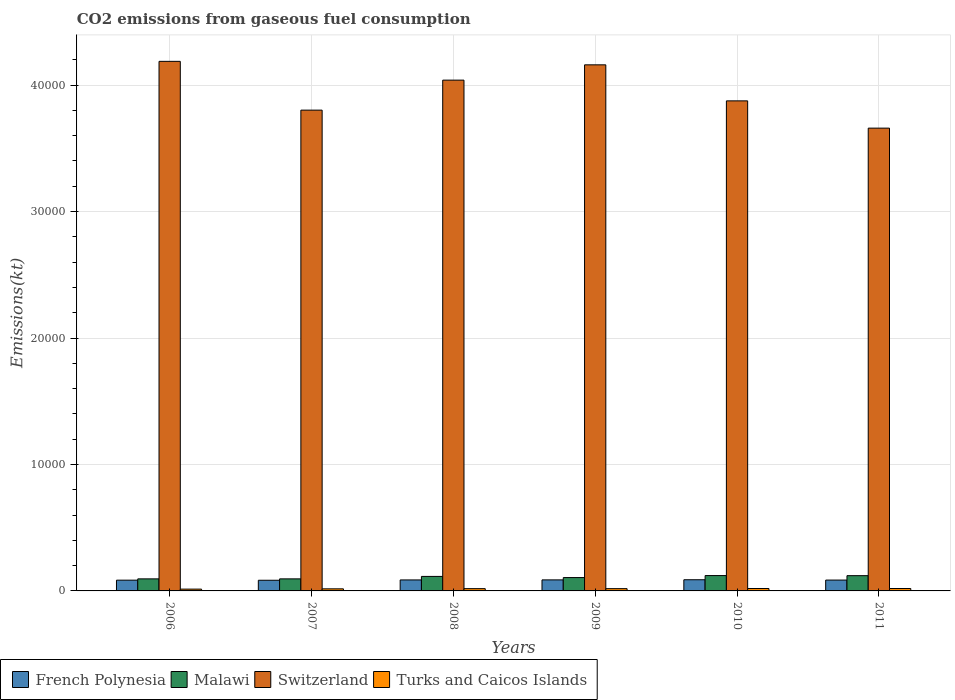How many bars are there on the 5th tick from the right?
Offer a very short reply. 4. What is the amount of CO2 emitted in Turks and Caicos Islands in 2011?
Give a very brief answer. 190.68. Across all years, what is the maximum amount of CO2 emitted in French Polynesia?
Ensure brevity in your answer.  883.75. Across all years, what is the minimum amount of CO2 emitted in Malawi?
Your answer should be compact. 953.42. In which year was the amount of CO2 emitted in Turks and Caicos Islands maximum?
Make the answer very short. 2010. What is the total amount of CO2 emitted in French Polynesia in the graph?
Ensure brevity in your answer.  5177.8. What is the difference between the amount of CO2 emitted in French Polynesia in 2006 and that in 2007?
Your answer should be very brief. 7.33. What is the difference between the amount of CO2 emitted in Switzerland in 2011 and the amount of CO2 emitted in French Polynesia in 2010?
Provide a short and direct response. 3.57e+04. What is the average amount of CO2 emitted in French Polynesia per year?
Provide a short and direct response. 862.97. In the year 2006, what is the difference between the amount of CO2 emitted in French Polynesia and amount of CO2 emitted in Malawi?
Make the answer very short. -102.68. In how many years, is the amount of CO2 emitted in Switzerland greater than 30000 kt?
Your response must be concise. 6. What is the ratio of the amount of CO2 emitted in Malawi in 2009 to that in 2011?
Provide a short and direct response. 0.88. Is the amount of CO2 emitted in French Polynesia in 2007 less than that in 2008?
Give a very brief answer. Yes. What is the difference between the highest and the second highest amount of CO2 emitted in Malawi?
Your response must be concise. 7.33. What is the difference between the highest and the lowest amount of CO2 emitted in Malawi?
Provide a succinct answer. 260.36. In how many years, is the amount of CO2 emitted in Turks and Caicos Islands greater than the average amount of CO2 emitted in Turks and Caicos Islands taken over all years?
Offer a terse response. 4. Is it the case that in every year, the sum of the amount of CO2 emitted in French Polynesia and amount of CO2 emitted in Turks and Caicos Islands is greater than the sum of amount of CO2 emitted in Switzerland and amount of CO2 emitted in Malawi?
Ensure brevity in your answer.  No. What does the 2nd bar from the left in 2009 represents?
Ensure brevity in your answer.  Malawi. What does the 4th bar from the right in 2007 represents?
Provide a short and direct response. French Polynesia. Is it the case that in every year, the sum of the amount of CO2 emitted in Switzerland and amount of CO2 emitted in Turks and Caicos Islands is greater than the amount of CO2 emitted in Malawi?
Offer a terse response. Yes. What is the difference between two consecutive major ticks on the Y-axis?
Offer a terse response. 10000. Are the values on the major ticks of Y-axis written in scientific E-notation?
Provide a succinct answer. No. Does the graph contain any zero values?
Provide a succinct answer. No. Does the graph contain grids?
Ensure brevity in your answer.  Yes. Where does the legend appear in the graph?
Keep it short and to the point. Bottom left. How many legend labels are there?
Your answer should be very brief. 4. What is the title of the graph?
Provide a succinct answer. CO2 emissions from gaseous fuel consumption. What is the label or title of the Y-axis?
Give a very brief answer. Emissions(kt). What is the Emissions(kt) in French Polynesia in 2006?
Provide a short and direct response. 850.74. What is the Emissions(kt) of Malawi in 2006?
Your answer should be compact. 953.42. What is the Emissions(kt) of Switzerland in 2006?
Keep it short and to the point. 4.19e+04. What is the Emissions(kt) of Turks and Caicos Islands in 2006?
Keep it short and to the point. 143.01. What is the Emissions(kt) of French Polynesia in 2007?
Provide a short and direct response. 843.41. What is the Emissions(kt) of Malawi in 2007?
Provide a succinct answer. 953.42. What is the Emissions(kt) of Switzerland in 2007?
Your response must be concise. 3.80e+04. What is the Emissions(kt) in Turks and Caicos Islands in 2007?
Give a very brief answer. 165.01. What is the Emissions(kt) in French Polynesia in 2008?
Offer a very short reply. 869.08. What is the Emissions(kt) of Malawi in 2008?
Provide a short and direct response. 1147.77. What is the Emissions(kt) of Switzerland in 2008?
Provide a short and direct response. 4.04e+04. What is the Emissions(kt) of Turks and Caicos Islands in 2008?
Your answer should be compact. 179.68. What is the Emissions(kt) in French Polynesia in 2009?
Your answer should be compact. 872.75. What is the Emissions(kt) of Malawi in 2009?
Your answer should be compact. 1056.1. What is the Emissions(kt) in Switzerland in 2009?
Make the answer very short. 4.16e+04. What is the Emissions(kt) in Turks and Caicos Islands in 2009?
Offer a terse response. 179.68. What is the Emissions(kt) of French Polynesia in 2010?
Provide a succinct answer. 883.75. What is the Emissions(kt) of Malawi in 2010?
Give a very brief answer. 1213.78. What is the Emissions(kt) in Switzerland in 2010?
Your answer should be compact. 3.88e+04. What is the Emissions(kt) in Turks and Caicos Islands in 2010?
Provide a short and direct response. 190.68. What is the Emissions(kt) of French Polynesia in 2011?
Provide a short and direct response. 858.08. What is the Emissions(kt) in Malawi in 2011?
Ensure brevity in your answer.  1206.44. What is the Emissions(kt) in Switzerland in 2011?
Offer a terse response. 3.66e+04. What is the Emissions(kt) in Turks and Caicos Islands in 2011?
Your answer should be very brief. 190.68. Across all years, what is the maximum Emissions(kt) of French Polynesia?
Your answer should be very brief. 883.75. Across all years, what is the maximum Emissions(kt) of Malawi?
Provide a succinct answer. 1213.78. Across all years, what is the maximum Emissions(kt) of Switzerland?
Give a very brief answer. 4.19e+04. Across all years, what is the maximum Emissions(kt) of Turks and Caicos Islands?
Your answer should be compact. 190.68. Across all years, what is the minimum Emissions(kt) in French Polynesia?
Make the answer very short. 843.41. Across all years, what is the minimum Emissions(kt) in Malawi?
Offer a very short reply. 953.42. Across all years, what is the minimum Emissions(kt) of Switzerland?
Your answer should be very brief. 3.66e+04. Across all years, what is the minimum Emissions(kt) of Turks and Caicos Islands?
Ensure brevity in your answer.  143.01. What is the total Emissions(kt) in French Polynesia in the graph?
Offer a terse response. 5177.8. What is the total Emissions(kt) of Malawi in the graph?
Give a very brief answer. 6530.93. What is the total Emissions(kt) in Switzerland in the graph?
Ensure brevity in your answer.  2.37e+05. What is the total Emissions(kt) in Turks and Caicos Islands in the graph?
Offer a very short reply. 1048.76. What is the difference between the Emissions(kt) in French Polynesia in 2006 and that in 2007?
Provide a succinct answer. 7.33. What is the difference between the Emissions(kt) of Switzerland in 2006 and that in 2007?
Give a very brief answer. 3857.68. What is the difference between the Emissions(kt) in Turks and Caicos Islands in 2006 and that in 2007?
Give a very brief answer. -22. What is the difference between the Emissions(kt) of French Polynesia in 2006 and that in 2008?
Provide a succinct answer. -18.34. What is the difference between the Emissions(kt) of Malawi in 2006 and that in 2008?
Offer a terse response. -194.35. What is the difference between the Emissions(kt) in Switzerland in 2006 and that in 2008?
Ensure brevity in your answer.  1485.13. What is the difference between the Emissions(kt) in Turks and Caicos Islands in 2006 and that in 2008?
Provide a short and direct response. -36.67. What is the difference between the Emissions(kt) in French Polynesia in 2006 and that in 2009?
Your answer should be very brief. -22. What is the difference between the Emissions(kt) in Malawi in 2006 and that in 2009?
Offer a terse response. -102.68. What is the difference between the Emissions(kt) of Switzerland in 2006 and that in 2009?
Make the answer very short. 275.02. What is the difference between the Emissions(kt) of Turks and Caicos Islands in 2006 and that in 2009?
Your response must be concise. -36.67. What is the difference between the Emissions(kt) of French Polynesia in 2006 and that in 2010?
Ensure brevity in your answer.  -33. What is the difference between the Emissions(kt) in Malawi in 2006 and that in 2010?
Your response must be concise. -260.36. What is the difference between the Emissions(kt) of Switzerland in 2006 and that in 2010?
Offer a very short reply. 3124.28. What is the difference between the Emissions(kt) in Turks and Caicos Islands in 2006 and that in 2010?
Offer a very short reply. -47.67. What is the difference between the Emissions(kt) of French Polynesia in 2006 and that in 2011?
Offer a very short reply. -7.33. What is the difference between the Emissions(kt) of Malawi in 2006 and that in 2011?
Make the answer very short. -253.02. What is the difference between the Emissions(kt) in Switzerland in 2006 and that in 2011?
Make the answer very short. 5280.48. What is the difference between the Emissions(kt) in Turks and Caicos Islands in 2006 and that in 2011?
Your answer should be compact. -47.67. What is the difference between the Emissions(kt) in French Polynesia in 2007 and that in 2008?
Provide a short and direct response. -25.67. What is the difference between the Emissions(kt) in Malawi in 2007 and that in 2008?
Keep it short and to the point. -194.35. What is the difference between the Emissions(kt) of Switzerland in 2007 and that in 2008?
Provide a short and direct response. -2372.55. What is the difference between the Emissions(kt) in Turks and Caicos Islands in 2007 and that in 2008?
Ensure brevity in your answer.  -14.67. What is the difference between the Emissions(kt) in French Polynesia in 2007 and that in 2009?
Give a very brief answer. -29.34. What is the difference between the Emissions(kt) in Malawi in 2007 and that in 2009?
Keep it short and to the point. -102.68. What is the difference between the Emissions(kt) in Switzerland in 2007 and that in 2009?
Ensure brevity in your answer.  -3582.66. What is the difference between the Emissions(kt) in Turks and Caicos Islands in 2007 and that in 2009?
Your answer should be very brief. -14.67. What is the difference between the Emissions(kt) in French Polynesia in 2007 and that in 2010?
Offer a terse response. -40.34. What is the difference between the Emissions(kt) in Malawi in 2007 and that in 2010?
Provide a succinct answer. -260.36. What is the difference between the Emissions(kt) of Switzerland in 2007 and that in 2010?
Provide a succinct answer. -733.4. What is the difference between the Emissions(kt) in Turks and Caicos Islands in 2007 and that in 2010?
Ensure brevity in your answer.  -25.67. What is the difference between the Emissions(kt) in French Polynesia in 2007 and that in 2011?
Offer a terse response. -14.67. What is the difference between the Emissions(kt) in Malawi in 2007 and that in 2011?
Keep it short and to the point. -253.02. What is the difference between the Emissions(kt) in Switzerland in 2007 and that in 2011?
Keep it short and to the point. 1422.8. What is the difference between the Emissions(kt) of Turks and Caicos Islands in 2007 and that in 2011?
Give a very brief answer. -25.67. What is the difference between the Emissions(kt) of French Polynesia in 2008 and that in 2009?
Keep it short and to the point. -3.67. What is the difference between the Emissions(kt) of Malawi in 2008 and that in 2009?
Offer a terse response. 91.67. What is the difference between the Emissions(kt) in Switzerland in 2008 and that in 2009?
Offer a terse response. -1210.11. What is the difference between the Emissions(kt) in French Polynesia in 2008 and that in 2010?
Make the answer very short. -14.67. What is the difference between the Emissions(kt) in Malawi in 2008 and that in 2010?
Provide a short and direct response. -66.01. What is the difference between the Emissions(kt) of Switzerland in 2008 and that in 2010?
Your response must be concise. 1639.15. What is the difference between the Emissions(kt) of Turks and Caicos Islands in 2008 and that in 2010?
Provide a short and direct response. -11. What is the difference between the Emissions(kt) in French Polynesia in 2008 and that in 2011?
Your answer should be compact. 11. What is the difference between the Emissions(kt) in Malawi in 2008 and that in 2011?
Offer a terse response. -58.67. What is the difference between the Emissions(kt) in Switzerland in 2008 and that in 2011?
Provide a succinct answer. 3795.34. What is the difference between the Emissions(kt) of Turks and Caicos Islands in 2008 and that in 2011?
Your response must be concise. -11. What is the difference between the Emissions(kt) in French Polynesia in 2009 and that in 2010?
Your answer should be very brief. -11. What is the difference between the Emissions(kt) of Malawi in 2009 and that in 2010?
Give a very brief answer. -157.68. What is the difference between the Emissions(kt) of Switzerland in 2009 and that in 2010?
Ensure brevity in your answer.  2849.26. What is the difference between the Emissions(kt) of Turks and Caicos Islands in 2009 and that in 2010?
Offer a terse response. -11. What is the difference between the Emissions(kt) of French Polynesia in 2009 and that in 2011?
Make the answer very short. 14.67. What is the difference between the Emissions(kt) in Malawi in 2009 and that in 2011?
Give a very brief answer. -150.35. What is the difference between the Emissions(kt) of Switzerland in 2009 and that in 2011?
Keep it short and to the point. 5005.45. What is the difference between the Emissions(kt) of Turks and Caicos Islands in 2009 and that in 2011?
Provide a short and direct response. -11. What is the difference between the Emissions(kt) of French Polynesia in 2010 and that in 2011?
Your answer should be very brief. 25.67. What is the difference between the Emissions(kt) in Malawi in 2010 and that in 2011?
Ensure brevity in your answer.  7.33. What is the difference between the Emissions(kt) of Switzerland in 2010 and that in 2011?
Your answer should be very brief. 2156.2. What is the difference between the Emissions(kt) of French Polynesia in 2006 and the Emissions(kt) of Malawi in 2007?
Give a very brief answer. -102.68. What is the difference between the Emissions(kt) in French Polynesia in 2006 and the Emissions(kt) in Switzerland in 2007?
Offer a very short reply. -3.72e+04. What is the difference between the Emissions(kt) in French Polynesia in 2006 and the Emissions(kt) in Turks and Caicos Islands in 2007?
Provide a short and direct response. 685.73. What is the difference between the Emissions(kt) of Malawi in 2006 and the Emissions(kt) of Switzerland in 2007?
Offer a terse response. -3.71e+04. What is the difference between the Emissions(kt) of Malawi in 2006 and the Emissions(kt) of Turks and Caicos Islands in 2007?
Provide a succinct answer. 788.4. What is the difference between the Emissions(kt) of Switzerland in 2006 and the Emissions(kt) of Turks and Caicos Islands in 2007?
Offer a very short reply. 4.17e+04. What is the difference between the Emissions(kt) of French Polynesia in 2006 and the Emissions(kt) of Malawi in 2008?
Keep it short and to the point. -297.03. What is the difference between the Emissions(kt) of French Polynesia in 2006 and the Emissions(kt) of Switzerland in 2008?
Make the answer very short. -3.95e+04. What is the difference between the Emissions(kt) of French Polynesia in 2006 and the Emissions(kt) of Turks and Caicos Islands in 2008?
Ensure brevity in your answer.  671.06. What is the difference between the Emissions(kt) of Malawi in 2006 and the Emissions(kt) of Switzerland in 2008?
Make the answer very short. -3.94e+04. What is the difference between the Emissions(kt) of Malawi in 2006 and the Emissions(kt) of Turks and Caicos Islands in 2008?
Give a very brief answer. 773.74. What is the difference between the Emissions(kt) in Switzerland in 2006 and the Emissions(kt) in Turks and Caicos Islands in 2008?
Your answer should be compact. 4.17e+04. What is the difference between the Emissions(kt) of French Polynesia in 2006 and the Emissions(kt) of Malawi in 2009?
Make the answer very short. -205.35. What is the difference between the Emissions(kt) in French Polynesia in 2006 and the Emissions(kt) in Switzerland in 2009?
Your response must be concise. -4.08e+04. What is the difference between the Emissions(kt) in French Polynesia in 2006 and the Emissions(kt) in Turks and Caicos Islands in 2009?
Your response must be concise. 671.06. What is the difference between the Emissions(kt) of Malawi in 2006 and the Emissions(kt) of Switzerland in 2009?
Your response must be concise. -4.06e+04. What is the difference between the Emissions(kt) in Malawi in 2006 and the Emissions(kt) in Turks and Caicos Islands in 2009?
Make the answer very short. 773.74. What is the difference between the Emissions(kt) of Switzerland in 2006 and the Emissions(kt) of Turks and Caicos Islands in 2009?
Your answer should be compact. 4.17e+04. What is the difference between the Emissions(kt) in French Polynesia in 2006 and the Emissions(kt) in Malawi in 2010?
Your answer should be compact. -363.03. What is the difference between the Emissions(kt) in French Polynesia in 2006 and the Emissions(kt) in Switzerland in 2010?
Ensure brevity in your answer.  -3.79e+04. What is the difference between the Emissions(kt) in French Polynesia in 2006 and the Emissions(kt) in Turks and Caicos Islands in 2010?
Give a very brief answer. 660.06. What is the difference between the Emissions(kt) of Malawi in 2006 and the Emissions(kt) of Switzerland in 2010?
Your response must be concise. -3.78e+04. What is the difference between the Emissions(kt) of Malawi in 2006 and the Emissions(kt) of Turks and Caicos Islands in 2010?
Keep it short and to the point. 762.74. What is the difference between the Emissions(kt) in Switzerland in 2006 and the Emissions(kt) in Turks and Caicos Islands in 2010?
Offer a terse response. 4.17e+04. What is the difference between the Emissions(kt) in French Polynesia in 2006 and the Emissions(kt) in Malawi in 2011?
Provide a succinct answer. -355.7. What is the difference between the Emissions(kt) of French Polynesia in 2006 and the Emissions(kt) of Switzerland in 2011?
Your answer should be very brief. -3.57e+04. What is the difference between the Emissions(kt) of French Polynesia in 2006 and the Emissions(kt) of Turks and Caicos Islands in 2011?
Your answer should be compact. 660.06. What is the difference between the Emissions(kt) of Malawi in 2006 and the Emissions(kt) of Switzerland in 2011?
Keep it short and to the point. -3.56e+04. What is the difference between the Emissions(kt) of Malawi in 2006 and the Emissions(kt) of Turks and Caicos Islands in 2011?
Your answer should be very brief. 762.74. What is the difference between the Emissions(kt) of Switzerland in 2006 and the Emissions(kt) of Turks and Caicos Islands in 2011?
Offer a very short reply. 4.17e+04. What is the difference between the Emissions(kt) of French Polynesia in 2007 and the Emissions(kt) of Malawi in 2008?
Give a very brief answer. -304.36. What is the difference between the Emissions(kt) of French Polynesia in 2007 and the Emissions(kt) of Switzerland in 2008?
Provide a short and direct response. -3.95e+04. What is the difference between the Emissions(kt) in French Polynesia in 2007 and the Emissions(kt) in Turks and Caicos Islands in 2008?
Offer a very short reply. 663.73. What is the difference between the Emissions(kt) of Malawi in 2007 and the Emissions(kt) of Switzerland in 2008?
Ensure brevity in your answer.  -3.94e+04. What is the difference between the Emissions(kt) of Malawi in 2007 and the Emissions(kt) of Turks and Caicos Islands in 2008?
Your answer should be compact. 773.74. What is the difference between the Emissions(kt) in Switzerland in 2007 and the Emissions(kt) in Turks and Caicos Islands in 2008?
Provide a short and direct response. 3.78e+04. What is the difference between the Emissions(kt) of French Polynesia in 2007 and the Emissions(kt) of Malawi in 2009?
Offer a very short reply. -212.69. What is the difference between the Emissions(kt) in French Polynesia in 2007 and the Emissions(kt) in Switzerland in 2009?
Your answer should be compact. -4.08e+04. What is the difference between the Emissions(kt) of French Polynesia in 2007 and the Emissions(kt) of Turks and Caicos Islands in 2009?
Your answer should be compact. 663.73. What is the difference between the Emissions(kt) in Malawi in 2007 and the Emissions(kt) in Switzerland in 2009?
Provide a short and direct response. -4.06e+04. What is the difference between the Emissions(kt) in Malawi in 2007 and the Emissions(kt) in Turks and Caicos Islands in 2009?
Your answer should be compact. 773.74. What is the difference between the Emissions(kt) in Switzerland in 2007 and the Emissions(kt) in Turks and Caicos Islands in 2009?
Offer a terse response. 3.78e+04. What is the difference between the Emissions(kt) of French Polynesia in 2007 and the Emissions(kt) of Malawi in 2010?
Offer a terse response. -370.37. What is the difference between the Emissions(kt) in French Polynesia in 2007 and the Emissions(kt) in Switzerland in 2010?
Your answer should be very brief. -3.79e+04. What is the difference between the Emissions(kt) in French Polynesia in 2007 and the Emissions(kt) in Turks and Caicos Islands in 2010?
Your answer should be compact. 652.73. What is the difference between the Emissions(kt) in Malawi in 2007 and the Emissions(kt) in Switzerland in 2010?
Provide a succinct answer. -3.78e+04. What is the difference between the Emissions(kt) of Malawi in 2007 and the Emissions(kt) of Turks and Caicos Islands in 2010?
Offer a terse response. 762.74. What is the difference between the Emissions(kt) of Switzerland in 2007 and the Emissions(kt) of Turks and Caicos Islands in 2010?
Give a very brief answer. 3.78e+04. What is the difference between the Emissions(kt) of French Polynesia in 2007 and the Emissions(kt) of Malawi in 2011?
Offer a very short reply. -363.03. What is the difference between the Emissions(kt) of French Polynesia in 2007 and the Emissions(kt) of Switzerland in 2011?
Your answer should be compact. -3.58e+04. What is the difference between the Emissions(kt) in French Polynesia in 2007 and the Emissions(kt) in Turks and Caicos Islands in 2011?
Make the answer very short. 652.73. What is the difference between the Emissions(kt) in Malawi in 2007 and the Emissions(kt) in Switzerland in 2011?
Offer a terse response. -3.56e+04. What is the difference between the Emissions(kt) in Malawi in 2007 and the Emissions(kt) in Turks and Caicos Islands in 2011?
Give a very brief answer. 762.74. What is the difference between the Emissions(kt) in Switzerland in 2007 and the Emissions(kt) in Turks and Caicos Islands in 2011?
Your response must be concise. 3.78e+04. What is the difference between the Emissions(kt) in French Polynesia in 2008 and the Emissions(kt) in Malawi in 2009?
Make the answer very short. -187.02. What is the difference between the Emissions(kt) in French Polynesia in 2008 and the Emissions(kt) in Switzerland in 2009?
Your answer should be very brief. -4.07e+04. What is the difference between the Emissions(kt) in French Polynesia in 2008 and the Emissions(kt) in Turks and Caicos Islands in 2009?
Make the answer very short. 689.4. What is the difference between the Emissions(kt) in Malawi in 2008 and the Emissions(kt) in Switzerland in 2009?
Make the answer very short. -4.05e+04. What is the difference between the Emissions(kt) in Malawi in 2008 and the Emissions(kt) in Turks and Caicos Islands in 2009?
Your answer should be compact. 968.09. What is the difference between the Emissions(kt) in Switzerland in 2008 and the Emissions(kt) in Turks and Caicos Islands in 2009?
Offer a terse response. 4.02e+04. What is the difference between the Emissions(kt) of French Polynesia in 2008 and the Emissions(kt) of Malawi in 2010?
Make the answer very short. -344.7. What is the difference between the Emissions(kt) in French Polynesia in 2008 and the Emissions(kt) in Switzerland in 2010?
Offer a terse response. -3.79e+04. What is the difference between the Emissions(kt) of French Polynesia in 2008 and the Emissions(kt) of Turks and Caicos Islands in 2010?
Offer a terse response. 678.39. What is the difference between the Emissions(kt) in Malawi in 2008 and the Emissions(kt) in Switzerland in 2010?
Keep it short and to the point. -3.76e+04. What is the difference between the Emissions(kt) of Malawi in 2008 and the Emissions(kt) of Turks and Caicos Islands in 2010?
Your answer should be compact. 957.09. What is the difference between the Emissions(kt) of Switzerland in 2008 and the Emissions(kt) of Turks and Caicos Islands in 2010?
Your answer should be compact. 4.02e+04. What is the difference between the Emissions(kt) in French Polynesia in 2008 and the Emissions(kt) in Malawi in 2011?
Ensure brevity in your answer.  -337.36. What is the difference between the Emissions(kt) of French Polynesia in 2008 and the Emissions(kt) of Switzerland in 2011?
Ensure brevity in your answer.  -3.57e+04. What is the difference between the Emissions(kt) in French Polynesia in 2008 and the Emissions(kt) in Turks and Caicos Islands in 2011?
Offer a terse response. 678.39. What is the difference between the Emissions(kt) of Malawi in 2008 and the Emissions(kt) of Switzerland in 2011?
Make the answer very short. -3.54e+04. What is the difference between the Emissions(kt) in Malawi in 2008 and the Emissions(kt) in Turks and Caicos Islands in 2011?
Offer a terse response. 957.09. What is the difference between the Emissions(kt) in Switzerland in 2008 and the Emissions(kt) in Turks and Caicos Islands in 2011?
Give a very brief answer. 4.02e+04. What is the difference between the Emissions(kt) of French Polynesia in 2009 and the Emissions(kt) of Malawi in 2010?
Keep it short and to the point. -341.03. What is the difference between the Emissions(kt) in French Polynesia in 2009 and the Emissions(kt) in Switzerland in 2010?
Make the answer very short. -3.79e+04. What is the difference between the Emissions(kt) of French Polynesia in 2009 and the Emissions(kt) of Turks and Caicos Islands in 2010?
Provide a short and direct response. 682.06. What is the difference between the Emissions(kt) in Malawi in 2009 and the Emissions(kt) in Switzerland in 2010?
Provide a short and direct response. -3.77e+04. What is the difference between the Emissions(kt) in Malawi in 2009 and the Emissions(kt) in Turks and Caicos Islands in 2010?
Ensure brevity in your answer.  865.41. What is the difference between the Emissions(kt) of Switzerland in 2009 and the Emissions(kt) of Turks and Caicos Islands in 2010?
Offer a very short reply. 4.14e+04. What is the difference between the Emissions(kt) in French Polynesia in 2009 and the Emissions(kt) in Malawi in 2011?
Your response must be concise. -333.7. What is the difference between the Emissions(kt) of French Polynesia in 2009 and the Emissions(kt) of Switzerland in 2011?
Provide a succinct answer. -3.57e+04. What is the difference between the Emissions(kt) in French Polynesia in 2009 and the Emissions(kt) in Turks and Caicos Islands in 2011?
Offer a terse response. 682.06. What is the difference between the Emissions(kt) in Malawi in 2009 and the Emissions(kt) in Switzerland in 2011?
Provide a short and direct response. -3.55e+04. What is the difference between the Emissions(kt) in Malawi in 2009 and the Emissions(kt) in Turks and Caicos Islands in 2011?
Your answer should be compact. 865.41. What is the difference between the Emissions(kt) of Switzerland in 2009 and the Emissions(kt) of Turks and Caicos Islands in 2011?
Offer a terse response. 4.14e+04. What is the difference between the Emissions(kt) in French Polynesia in 2010 and the Emissions(kt) in Malawi in 2011?
Offer a terse response. -322.7. What is the difference between the Emissions(kt) of French Polynesia in 2010 and the Emissions(kt) of Switzerland in 2011?
Provide a succinct answer. -3.57e+04. What is the difference between the Emissions(kt) of French Polynesia in 2010 and the Emissions(kt) of Turks and Caicos Islands in 2011?
Give a very brief answer. 693.06. What is the difference between the Emissions(kt) of Malawi in 2010 and the Emissions(kt) of Switzerland in 2011?
Give a very brief answer. -3.54e+04. What is the difference between the Emissions(kt) of Malawi in 2010 and the Emissions(kt) of Turks and Caicos Islands in 2011?
Your answer should be compact. 1023.09. What is the difference between the Emissions(kt) in Switzerland in 2010 and the Emissions(kt) in Turks and Caicos Islands in 2011?
Offer a very short reply. 3.86e+04. What is the average Emissions(kt) in French Polynesia per year?
Provide a short and direct response. 862.97. What is the average Emissions(kt) in Malawi per year?
Offer a terse response. 1088.49. What is the average Emissions(kt) of Switzerland per year?
Your answer should be compact. 3.95e+04. What is the average Emissions(kt) in Turks and Caicos Islands per year?
Offer a terse response. 174.79. In the year 2006, what is the difference between the Emissions(kt) of French Polynesia and Emissions(kt) of Malawi?
Offer a terse response. -102.68. In the year 2006, what is the difference between the Emissions(kt) of French Polynesia and Emissions(kt) of Switzerland?
Give a very brief answer. -4.10e+04. In the year 2006, what is the difference between the Emissions(kt) of French Polynesia and Emissions(kt) of Turks and Caicos Islands?
Make the answer very short. 707.73. In the year 2006, what is the difference between the Emissions(kt) in Malawi and Emissions(kt) in Switzerland?
Make the answer very short. -4.09e+04. In the year 2006, what is the difference between the Emissions(kt) in Malawi and Emissions(kt) in Turks and Caicos Islands?
Keep it short and to the point. 810.41. In the year 2006, what is the difference between the Emissions(kt) of Switzerland and Emissions(kt) of Turks and Caicos Islands?
Ensure brevity in your answer.  4.17e+04. In the year 2007, what is the difference between the Emissions(kt) in French Polynesia and Emissions(kt) in Malawi?
Keep it short and to the point. -110.01. In the year 2007, what is the difference between the Emissions(kt) of French Polynesia and Emissions(kt) of Switzerland?
Provide a succinct answer. -3.72e+04. In the year 2007, what is the difference between the Emissions(kt) of French Polynesia and Emissions(kt) of Turks and Caicos Islands?
Give a very brief answer. 678.39. In the year 2007, what is the difference between the Emissions(kt) of Malawi and Emissions(kt) of Switzerland?
Your answer should be very brief. -3.71e+04. In the year 2007, what is the difference between the Emissions(kt) in Malawi and Emissions(kt) in Turks and Caicos Islands?
Make the answer very short. 788.4. In the year 2007, what is the difference between the Emissions(kt) in Switzerland and Emissions(kt) in Turks and Caicos Islands?
Your response must be concise. 3.79e+04. In the year 2008, what is the difference between the Emissions(kt) of French Polynesia and Emissions(kt) of Malawi?
Give a very brief answer. -278.69. In the year 2008, what is the difference between the Emissions(kt) of French Polynesia and Emissions(kt) of Switzerland?
Make the answer very short. -3.95e+04. In the year 2008, what is the difference between the Emissions(kt) in French Polynesia and Emissions(kt) in Turks and Caicos Islands?
Offer a terse response. 689.4. In the year 2008, what is the difference between the Emissions(kt) of Malawi and Emissions(kt) of Switzerland?
Your answer should be compact. -3.92e+04. In the year 2008, what is the difference between the Emissions(kt) in Malawi and Emissions(kt) in Turks and Caicos Islands?
Give a very brief answer. 968.09. In the year 2008, what is the difference between the Emissions(kt) in Switzerland and Emissions(kt) in Turks and Caicos Islands?
Offer a terse response. 4.02e+04. In the year 2009, what is the difference between the Emissions(kt) in French Polynesia and Emissions(kt) in Malawi?
Ensure brevity in your answer.  -183.35. In the year 2009, what is the difference between the Emissions(kt) of French Polynesia and Emissions(kt) of Switzerland?
Ensure brevity in your answer.  -4.07e+04. In the year 2009, what is the difference between the Emissions(kt) in French Polynesia and Emissions(kt) in Turks and Caicos Islands?
Your answer should be compact. 693.06. In the year 2009, what is the difference between the Emissions(kt) of Malawi and Emissions(kt) of Switzerland?
Offer a terse response. -4.05e+04. In the year 2009, what is the difference between the Emissions(kt) of Malawi and Emissions(kt) of Turks and Caicos Islands?
Offer a terse response. 876.41. In the year 2009, what is the difference between the Emissions(kt) in Switzerland and Emissions(kt) in Turks and Caicos Islands?
Keep it short and to the point. 4.14e+04. In the year 2010, what is the difference between the Emissions(kt) in French Polynesia and Emissions(kt) in Malawi?
Ensure brevity in your answer.  -330.03. In the year 2010, what is the difference between the Emissions(kt) in French Polynesia and Emissions(kt) in Switzerland?
Give a very brief answer. -3.79e+04. In the year 2010, what is the difference between the Emissions(kt) of French Polynesia and Emissions(kt) of Turks and Caicos Islands?
Your answer should be compact. 693.06. In the year 2010, what is the difference between the Emissions(kt) in Malawi and Emissions(kt) in Switzerland?
Give a very brief answer. -3.75e+04. In the year 2010, what is the difference between the Emissions(kt) in Malawi and Emissions(kt) in Turks and Caicos Islands?
Provide a short and direct response. 1023.09. In the year 2010, what is the difference between the Emissions(kt) in Switzerland and Emissions(kt) in Turks and Caicos Islands?
Give a very brief answer. 3.86e+04. In the year 2011, what is the difference between the Emissions(kt) in French Polynesia and Emissions(kt) in Malawi?
Ensure brevity in your answer.  -348.37. In the year 2011, what is the difference between the Emissions(kt) in French Polynesia and Emissions(kt) in Switzerland?
Offer a very short reply. -3.57e+04. In the year 2011, what is the difference between the Emissions(kt) in French Polynesia and Emissions(kt) in Turks and Caicos Islands?
Provide a short and direct response. 667.39. In the year 2011, what is the difference between the Emissions(kt) in Malawi and Emissions(kt) in Switzerland?
Make the answer very short. -3.54e+04. In the year 2011, what is the difference between the Emissions(kt) in Malawi and Emissions(kt) in Turks and Caicos Islands?
Ensure brevity in your answer.  1015.76. In the year 2011, what is the difference between the Emissions(kt) in Switzerland and Emissions(kt) in Turks and Caicos Islands?
Make the answer very short. 3.64e+04. What is the ratio of the Emissions(kt) in French Polynesia in 2006 to that in 2007?
Your answer should be very brief. 1.01. What is the ratio of the Emissions(kt) of Malawi in 2006 to that in 2007?
Your answer should be compact. 1. What is the ratio of the Emissions(kt) in Switzerland in 2006 to that in 2007?
Your response must be concise. 1.1. What is the ratio of the Emissions(kt) in Turks and Caicos Islands in 2006 to that in 2007?
Provide a short and direct response. 0.87. What is the ratio of the Emissions(kt) in French Polynesia in 2006 to that in 2008?
Your response must be concise. 0.98. What is the ratio of the Emissions(kt) of Malawi in 2006 to that in 2008?
Keep it short and to the point. 0.83. What is the ratio of the Emissions(kt) of Switzerland in 2006 to that in 2008?
Ensure brevity in your answer.  1.04. What is the ratio of the Emissions(kt) in Turks and Caicos Islands in 2006 to that in 2008?
Offer a terse response. 0.8. What is the ratio of the Emissions(kt) in French Polynesia in 2006 to that in 2009?
Your answer should be compact. 0.97. What is the ratio of the Emissions(kt) of Malawi in 2006 to that in 2009?
Your response must be concise. 0.9. What is the ratio of the Emissions(kt) in Switzerland in 2006 to that in 2009?
Keep it short and to the point. 1.01. What is the ratio of the Emissions(kt) of Turks and Caicos Islands in 2006 to that in 2009?
Your answer should be compact. 0.8. What is the ratio of the Emissions(kt) in French Polynesia in 2006 to that in 2010?
Your answer should be compact. 0.96. What is the ratio of the Emissions(kt) of Malawi in 2006 to that in 2010?
Your response must be concise. 0.79. What is the ratio of the Emissions(kt) of Switzerland in 2006 to that in 2010?
Offer a terse response. 1.08. What is the ratio of the Emissions(kt) in Turks and Caicos Islands in 2006 to that in 2010?
Provide a succinct answer. 0.75. What is the ratio of the Emissions(kt) in Malawi in 2006 to that in 2011?
Provide a short and direct response. 0.79. What is the ratio of the Emissions(kt) of Switzerland in 2006 to that in 2011?
Your response must be concise. 1.14. What is the ratio of the Emissions(kt) of French Polynesia in 2007 to that in 2008?
Make the answer very short. 0.97. What is the ratio of the Emissions(kt) in Malawi in 2007 to that in 2008?
Keep it short and to the point. 0.83. What is the ratio of the Emissions(kt) in Switzerland in 2007 to that in 2008?
Keep it short and to the point. 0.94. What is the ratio of the Emissions(kt) of Turks and Caicos Islands in 2007 to that in 2008?
Your response must be concise. 0.92. What is the ratio of the Emissions(kt) of French Polynesia in 2007 to that in 2009?
Ensure brevity in your answer.  0.97. What is the ratio of the Emissions(kt) in Malawi in 2007 to that in 2009?
Keep it short and to the point. 0.9. What is the ratio of the Emissions(kt) of Switzerland in 2007 to that in 2009?
Make the answer very short. 0.91. What is the ratio of the Emissions(kt) in Turks and Caicos Islands in 2007 to that in 2009?
Your answer should be very brief. 0.92. What is the ratio of the Emissions(kt) in French Polynesia in 2007 to that in 2010?
Offer a very short reply. 0.95. What is the ratio of the Emissions(kt) of Malawi in 2007 to that in 2010?
Offer a terse response. 0.79. What is the ratio of the Emissions(kt) of Switzerland in 2007 to that in 2010?
Offer a very short reply. 0.98. What is the ratio of the Emissions(kt) in Turks and Caicos Islands in 2007 to that in 2010?
Your answer should be compact. 0.87. What is the ratio of the Emissions(kt) of French Polynesia in 2007 to that in 2011?
Ensure brevity in your answer.  0.98. What is the ratio of the Emissions(kt) of Malawi in 2007 to that in 2011?
Provide a short and direct response. 0.79. What is the ratio of the Emissions(kt) in Switzerland in 2007 to that in 2011?
Provide a short and direct response. 1.04. What is the ratio of the Emissions(kt) of Turks and Caicos Islands in 2007 to that in 2011?
Your response must be concise. 0.87. What is the ratio of the Emissions(kt) in French Polynesia in 2008 to that in 2009?
Offer a very short reply. 1. What is the ratio of the Emissions(kt) in Malawi in 2008 to that in 2009?
Provide a succinct answer. 1.09. What is the ratio of the Emissions(kt) of Switzerland in 2008 to that in 2009?
Provide a short and direct response. 0.97. What is the ratio of the Emissions(kt) in French Polynesia in 2008 to that in 2010?
Offer a very short reply. 0.98. What is the ratio of the Emissions(kt) in Malawi in 2008 to that in 2010?
Your response must be concise. 0.95. What is the ratio of the Emissions(kt) of Switzerland in 2008 to that in 2010?
Your answer should be very brief. 1.04. What is the ratio of the Emissions(kt) of Turks and Caicos Islands in 2008 to that in 2010?
Keep it short and to the point. 0.94. What is the ratio of the Emissions(kt) of French Polynesia in 2008 to that in 2011?
Make the answer very short. 1.01. What is the ratio of the Emissions(kt) in Malawi in 2008 to that in 2011?
Your answer should be compact. 0.95. What is the ratio of the Emissions(kt) of Switzerland in 2008 to that in 2011?
Ensure brevity in your answer.  1.1. What is the ratio of the Emissions(kt) of Turks and Caicos Islands in 2008 to that in 2011?
Your answer should be compact. 0.94. What is the ratio of the Emissions(kt) in French Polynesia in 2009 to that in 2010?
Offer a very short reply. 0.99. What is the ratio of the Emissions(kt) in Malawi in 2009 to that in 2010?
Your answer should be very brief. 0.87. What is the ratio of the Emissions(kt) in Switzerland in 2009 to that in 2010?
Keep it short and to the point. 1.07. What is the ratio of the Emissions(kt) of Turks and Caicos Islands in 2009 to that in 2010?
Your answer should be very brief. 0.94. What is the ratio of the Emissions(kt) of French Polynesia in 2009 to that in 2011?
Your answer should be very brief. 1.02. What is the ratio of the Emissions(kt) in Malawi in 2009 to that in 2011?
Offer a terse response. 0.88. What is the ratio of the Emissions(kt) in Switzerland in 2009 to that in 2011?
Your answer should be compact. 1.14. What is the ratio of the Emissions(kt) in Turks and Caicos Islands in 2009 to that in 2011?
Ensure brevity in your answer.  0.94. What is the ratio of the Emissions(kt) in French Polynesia in 2010 to that in 2011?
Ensure brevity in your answer.  1.03. What is the ratio of the Emissions(kt) in Switzerland in 2010 to that in 2011?
Give a very brief answer. 1.06. What is the difference between the highest and the second highest Emissions(kt) in French Polynesia?
Make the answer very short. 11. What is the difference between the highest and the second highest Emissions(kt) in Malawi?
Ensure brevity in your answer.  7.33. What is the difference between the highest and the second highest Emissions(kt) of Switzerland?
Ensure brevity in your answer.  275.02. What is the difference between the highest and the second highest Emissions(kt) of Turks and Caicos Islands?
Offer a terse response. 0. What is the difference between the highest and the lowest Emissions(kt) in French Polynesia?
Make the answer very short. 40.34. What is the difference between the highest and the lowest Emissions(kt) of Malawi?
Your answer should be compact. 260.36. What is the difference between the highest and the lowest Emissions(kt) in Switzerland?
Offer a terse response. 5280.48. What is the difference between the highest and the lowest Emissions(kt) of Turks and Caicos Islands?
Your answer should be very brief. 47.67. 